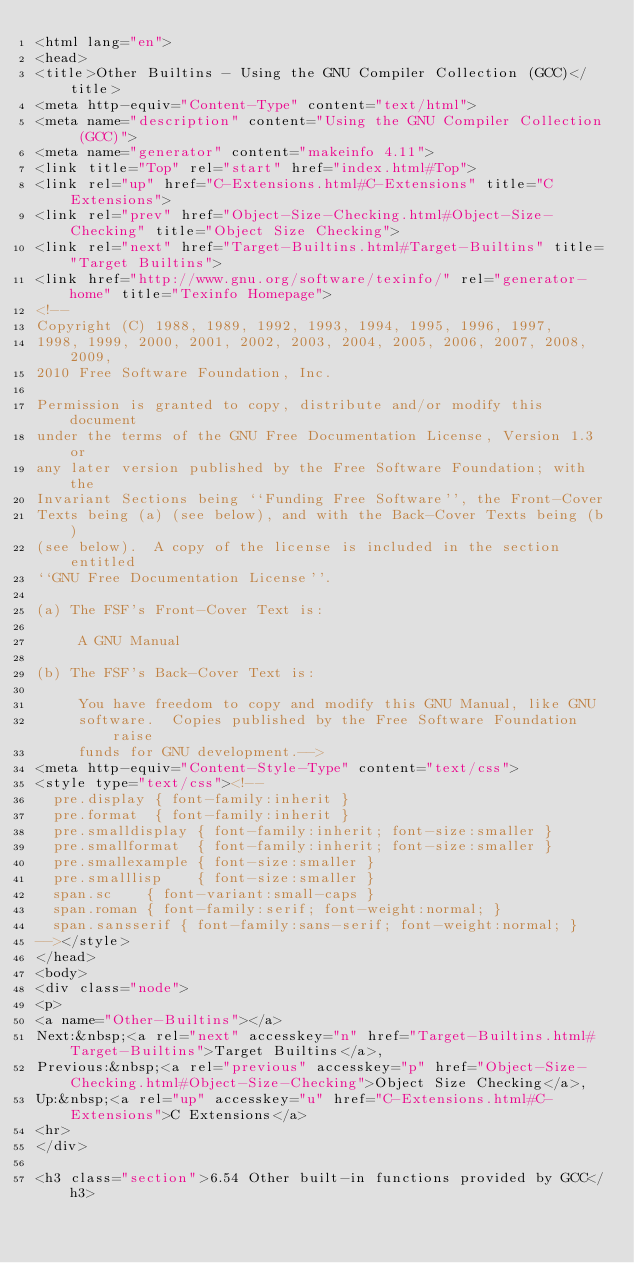Convert code to text. <code><loc_0><loc_0><loc_500><loc_500><_HTML_><html lang="en">
<head>
<title>Other Builtins - Using the GNU Compiler Collection (GCC)</title>
<meta http-equiv="Content-Type" content="text/html">
<meta name="description" content="Using the GNU Compiler Collection (GCC)">
<meta name="generator" content="makeinfo 4.11">
<link title="Top" rel="start" href="index.html#Top">
<link rel="up" href="C-Extensions.html#C-Extensions" title="C Extensions">
<link rel="prev" href="Object-Size-Checking.html#Object-Size-Checking" title="Object Size Checking">
<link rel="next" href="Target-Builtins.html#Target-Builtins" title="Target Builtins">
<link href="http://www.gnu.org/software/texinfo/" rel="generator-home" title="Texinfo Homepage">
<!--
Copyright (C) 1988, 1989, 1992, 1993, 1994, 1995, 1996, 1997,
1998, 1999, 2000, 2001, 2002, 2003, 2004, 2005, 2006, 2007, 2008, 2009,
2010 Free Software Foundation, Inc.

Permission is granted to copy, distribute and/or modify this document
under the terms of the GNU Free Documentation License, Version 1.3 or
any later version published by the Free Software Foundation; with the
Invariant Sections being ``Funding Free Software'', the Front-Cover
Texts being (a) (see below), and with the Back-Cover Texts being (b)
(see below).  A copy of the license is included in the section entitled
``GNU Free Documentation License''.

(a) The FSF's Front-Cover Text is:

     A GNU Manual

(b) The FSF's Back-Cover Text is:

     You have freedom to copy and modify this GNU Manual, like GNU
     software.  Copies published by the Free Software Foundation raise
     funds for GNU development.-->
<meta http-equiv="Content-Style-Type" content="text/css">
<style type="text/css"><!--
  pre.display { font-family:inherit }
  pre.format  { font-family:inherit }
  pre.smalldisplay { font-family:inherit; font-size:smaller }
  pre.smallformat  { font-family:inherit; font-size:smaller }
  pre.smallexample { font-size:smaller }
  pre.smalllisp    { font-size:smaller }
  span.sc    { font-variant:small-caps }
  span.roman { font-family:serif; font-weight:normal; } 
  span.sansserif { font-family:sans-serif; font-weight:normal; } 
--></style>
</head>
<body>
<div class="node">
<p>
<a name="Other-Builtins"></a>
Next:&nbsp;<a rel="next" accesskey="n" href="Target-Builtins.html#Target-Builtins">Target Builtins</a>,
Previous:&nbsp;<a rel="previous" accesskey="p" href="Object-Size-Checking.html#Object-Size-Checking">Object Size Checking</a>,
Up:&nbsp;<a rel="up" accesskey="u" href="C-Extensions.html#C-Extensions">C Extensions</a>
<hr>
</div>

<h3 class="section">6.54 Other built-in functions provided by GCC</h3>
</code> 